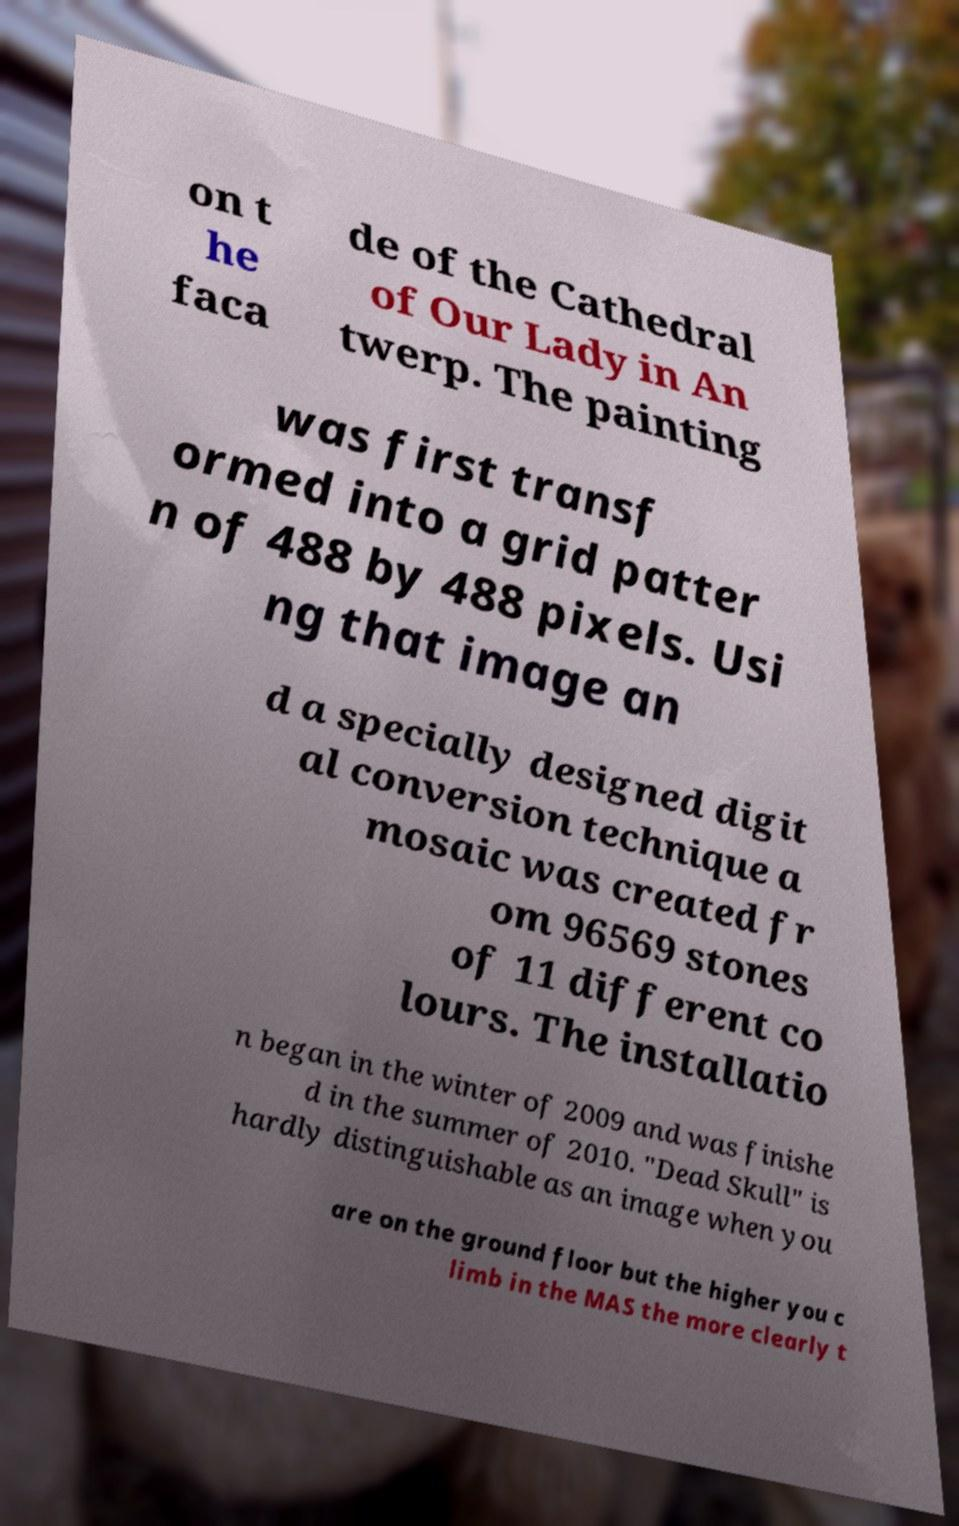Can you accurately transcribe the text from the provided image for me? on t he faca de of the Cathedral of Our Lady in An twerp. The painting was first transf ormed into a grid patter n of 488 by 488 pixels. Usi ng that image an d a specially designed digit al conversion technique a mosaic was created fr om 96569 stones of 11 different co lours. The installatio n began in the winter of 2009 and was finishe d in the summer of 2010. "Dead Skull" is hardly distinguishable as an image when you are on the ground floor but the higher you c limb in the MAS the more clearly t 